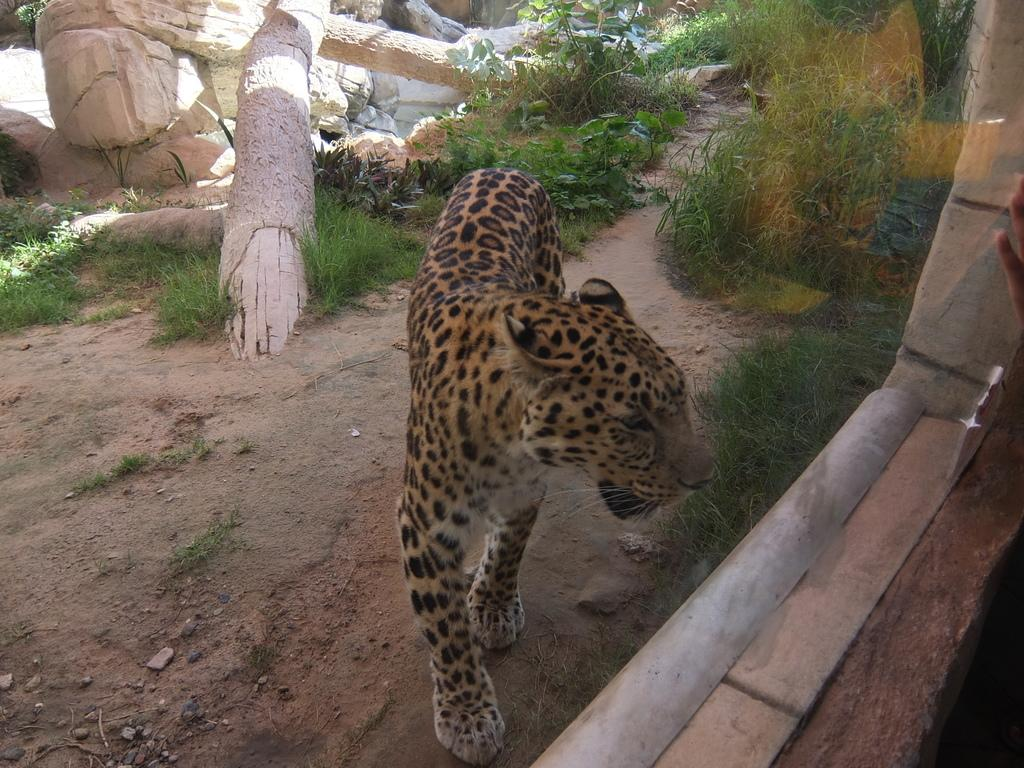What animal is the main subject of the image? There is a cheetah in the image. Where is the cheetah located in the image? The cheetah is on the ground. What can be seen in the background of the image? There are wooden poles and grass in the background of the image. What type of protest is taking place in the image? There is no protest present in the image; it features a cheetah on the ground with wooden poles and grass in the background. How does the cheetah turn around in the image? The cheetah does not turn around in the image; it is stationary on the ground. 